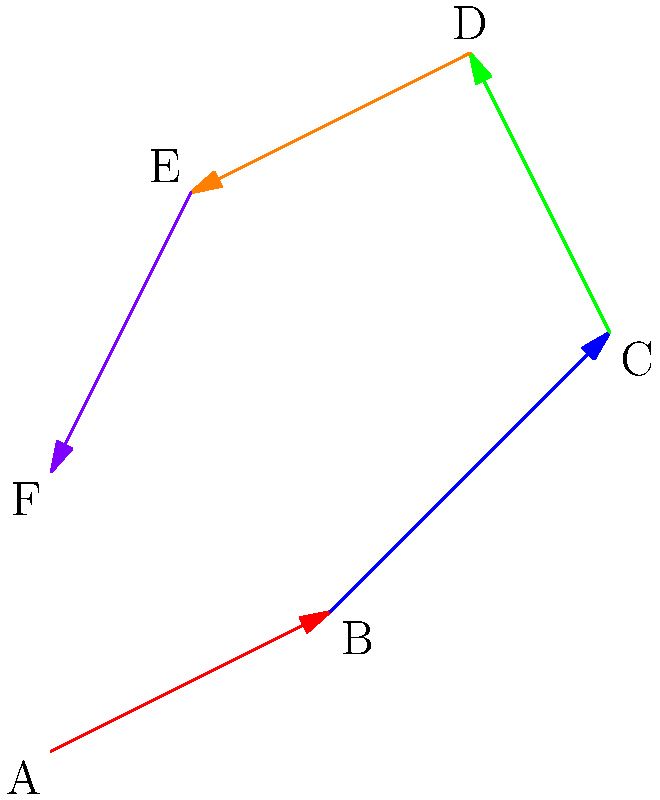Decipher the hidden message in this vector puzzle. Each arrow represents a letter, with its length corresponding to the letter's position in the alphabet (A=1, B=2, etc.) and its color indicating the word order (red, blue, green, orange, purple). What five-letter word is concealed within these vectors? To solve this puzzle, we need to follow these steps:

1. Determine the length of each vector:
   - Red (A to B): $\sqrt{2^2 + 1^2} \approx 2.24$
   - Blue (B to C): $\sqrt{2^2 + 2^2} = 2.83$
   - Green (C to D): $\sqrt{(-1)^2 + 2^2} \approx 2.24$
   - Orange (D to E): $\sqrt{(-2)^2 + (-1)^2} \approx 2.24$
   - Purple (E to F): $\sqrt{(-1)^2 + (-2)^2} \approx 2.24$

2. Round the lengths to the nearest whole number:
   - Red: 2
   - Blue: 3
   - Green: 2
   - Orange: 2
   - Purple: 2

3. Convert these numbers to letters (A=1, B=2, etc.):
   - 2 = B
   - 3 = C
   - 2 = B
   - 2 = B
   - 2 = B

4. Arrange the letters in the color order (red, blue, green, orange, purple):
   B C B B B

Therefore, the hidden five-letter word is "BCBBB".
Answer: BCBBB 